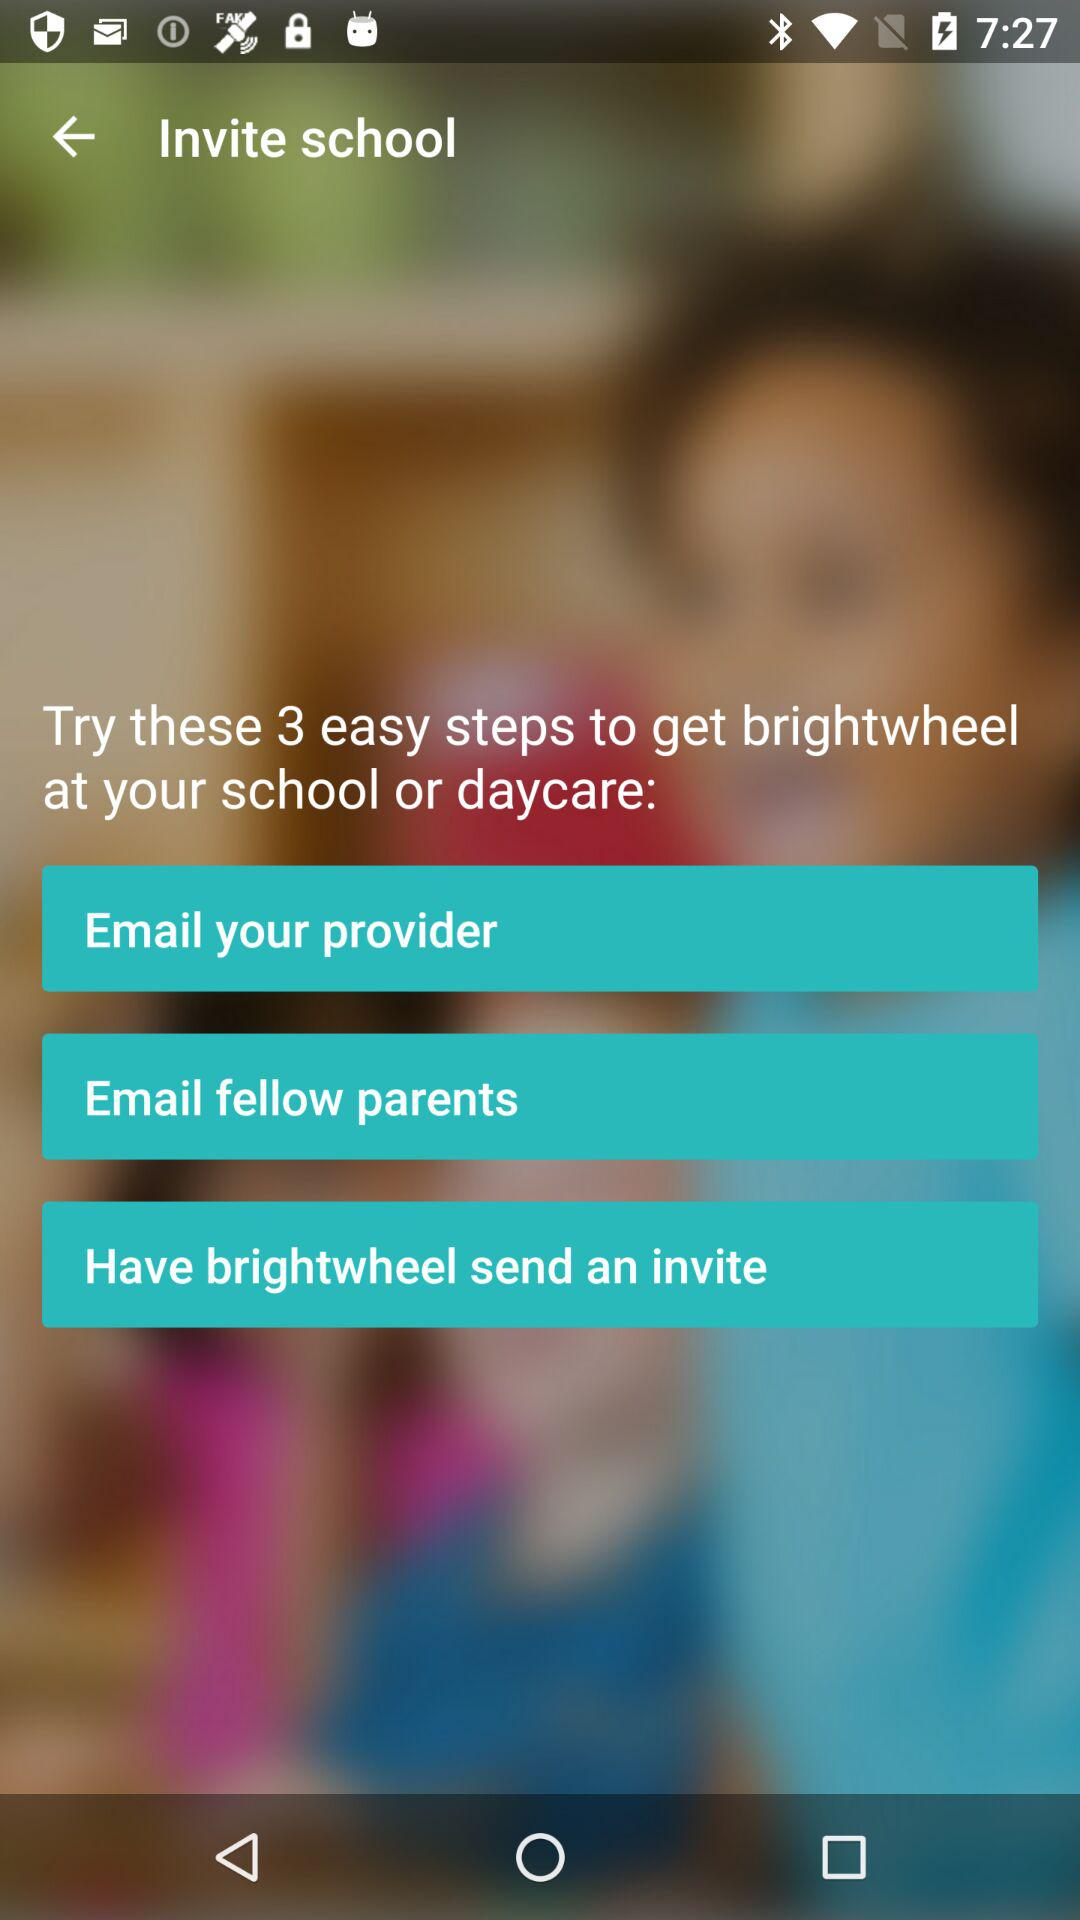What are the three steps to getting "brightwheel" at your school? The three steps are "Email your provider", "Email fellow parents" and "Have brightwheel send an invite". 